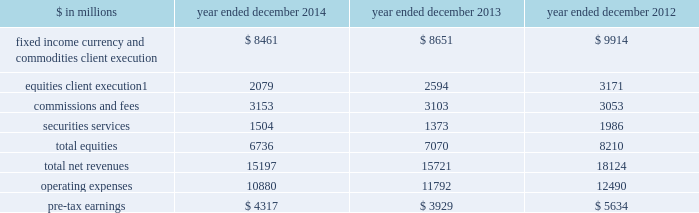Management 2019s discussion and analysis institutional client services our institutional client services segment is comprised of : fixed income , currency and commodities client execution .
Includes client execution activities related to making markets in interest rate products , credit products , mortgages , currencies and commodities .
2030 interest rate products .
Government bonds , money market instruments such as commercial paper , treasury bills , repurchase agreements and other highly liquid securities and instruments , as well as interest rate swaps , options and other derivatives .
2030 credit products .
Investment-grade corporate securities , high-yield securities , credit derivatives , bank and bridge loans , municipal securities , emerging market and distressed debt , and trade claims .
2030 mortgages .
Commercial mortgage-related securities , loans and derivatives , residential mortgage-related securities , loans and derivatives ( including u.s .
Government agency-issued collateralized mortgage obligations , other prime , subprime and alt-a securities and loans ) , and other asset-backed securities , loans and derivatives .
2030 currencies .
Most currencies , including growth-market currencies .
2030 commodities .
Crude oil and petroleum products , natural gas , base , precious and other metals , electricity , coal , agricultural and other commodity products .
Equities .
Includes client execution activities related to making markets in equity products and commissions and fees from executing and clearing institutional client transactions on major stock , options and futures exchanges worldwide , as well as otc transactions .
Equities also includes our securities services business , which provides financing , securities lending and other prime brokerage services to institutional clients , including hedge funds , mutual funds , pension funds and foundations , and generates revenues primarily in the form of interest rate spreads or fees .
The table below presents the operating results of our institutional client services segment. .
Net revenues related to the americas reinsurance business were $ 317 million for 2013 and $ 1.08 billion for 2012 .
In april 2013 , we completed the sale of a majority stake in our americas reinsurance business and no longer consolidate this business .
42 goldman sachs 2014 annual report .
What was the percentage change in pre-tax earnings for the institutional client services segment between 2012 and 2013? 
Computations: ((3929 - 5634) / 5634)
Answer: -0.30263. 